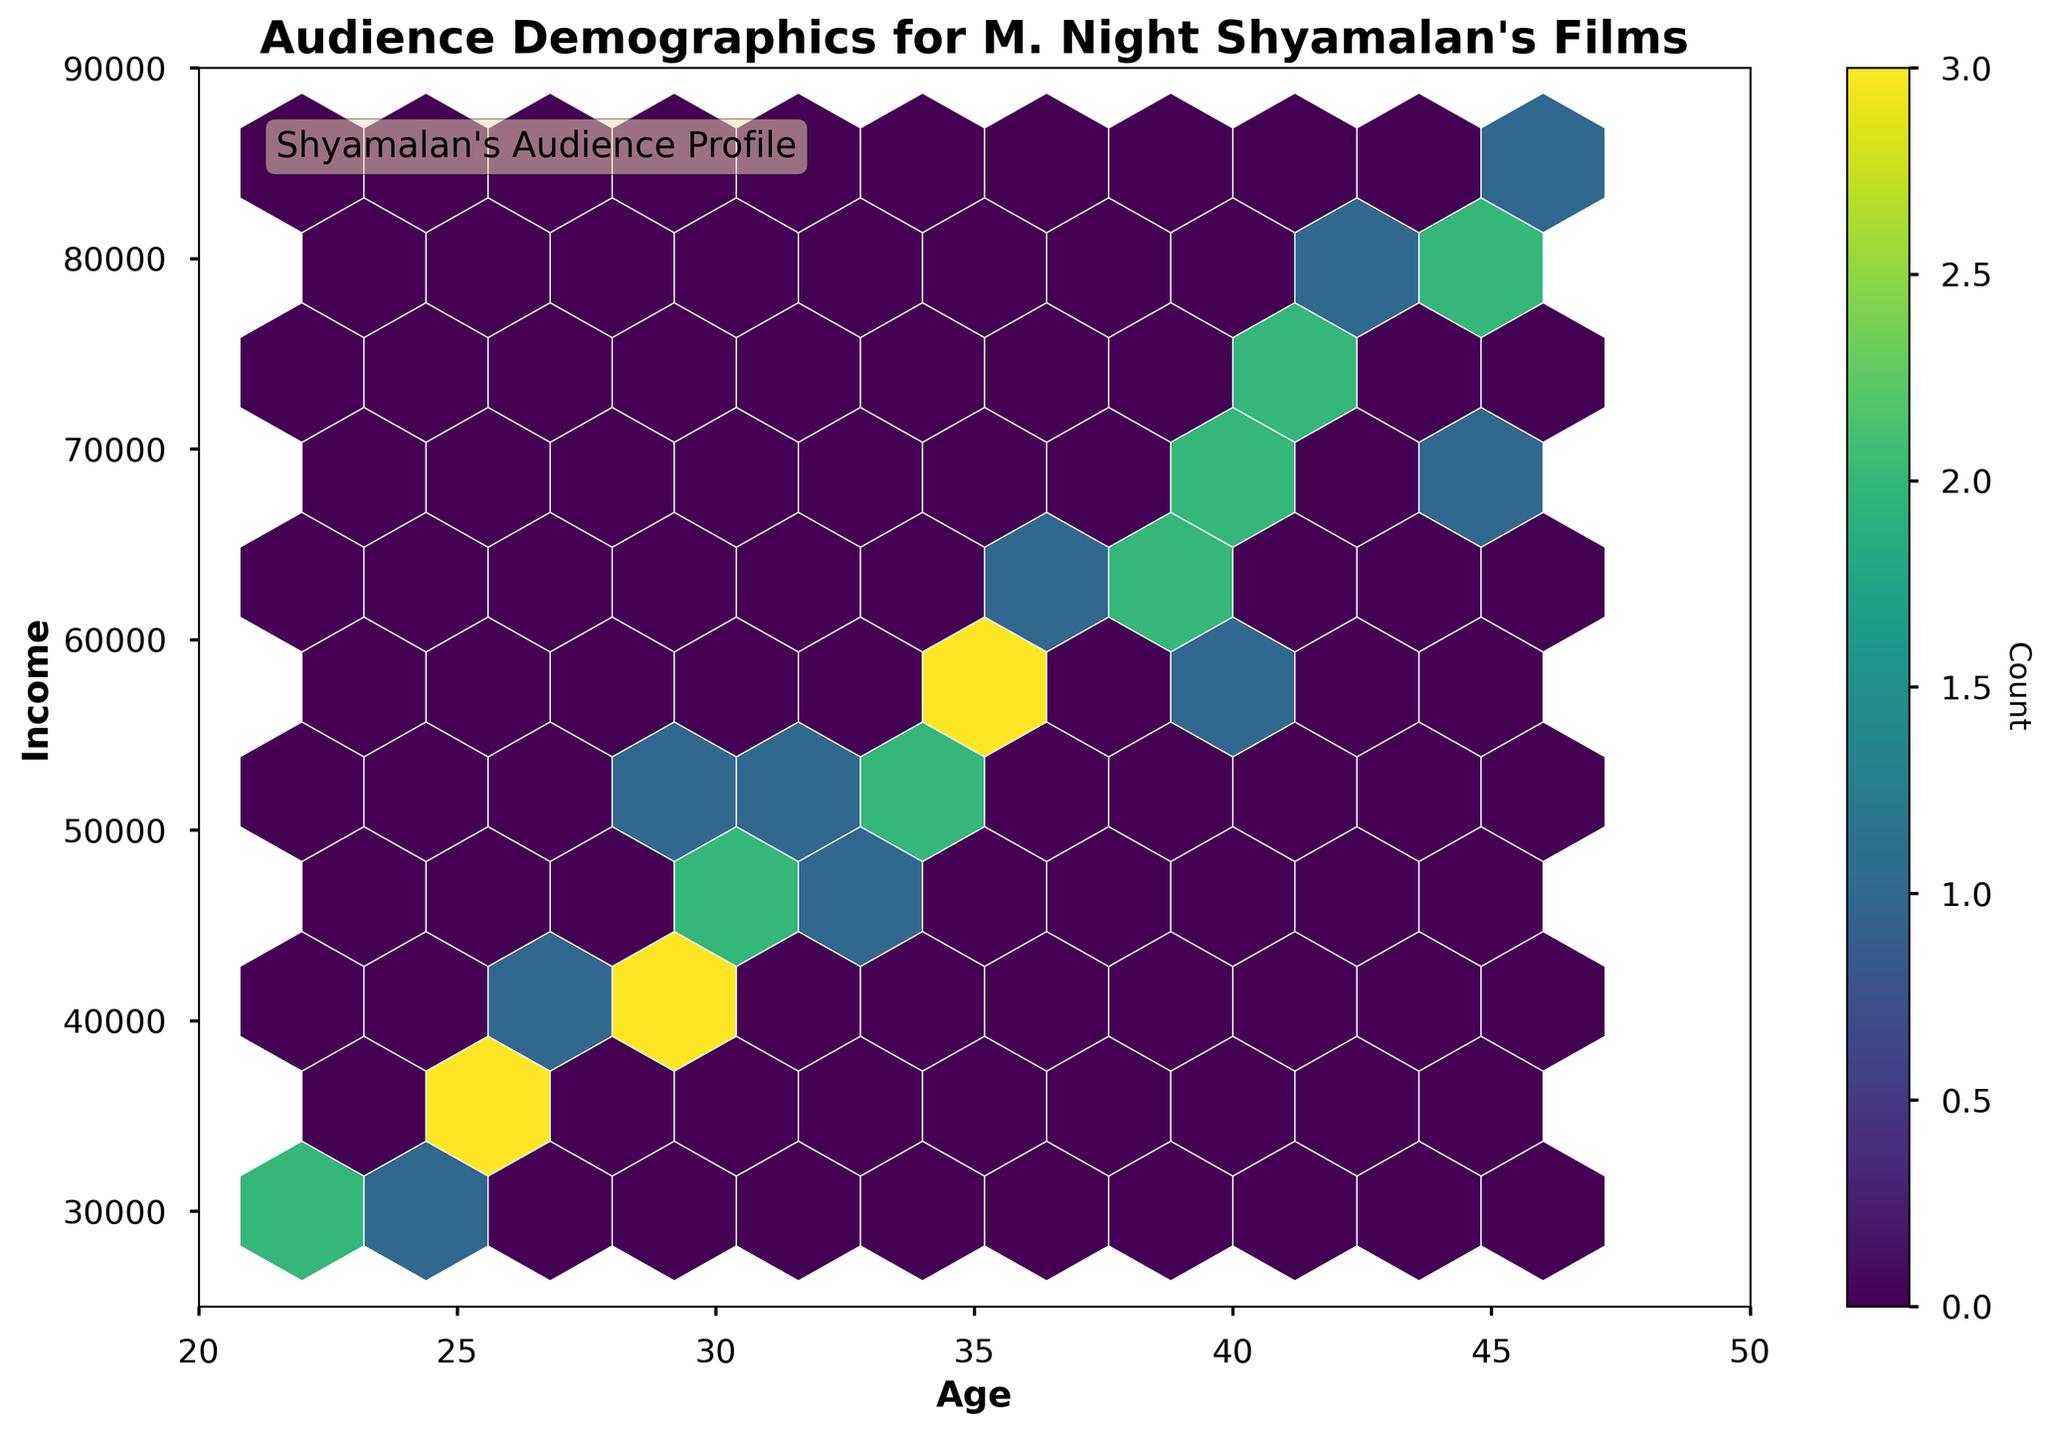How is the distribution of audience age and income depicted? The distribution is shown through a hexbin plot, where hexagonal bins are colored to depict the density of data points. Darker colors indicate higher concentrations of audience members in those age and income brackets.
Answer: Through hexagonal bins with varying color intensities What is the average income range for the age group 25-30? By visually inspecting the hexbin density within the age range 25-30 on the x-axis, the concentration of data points lies between income levels of $35,000 to $50,000.
Answer: $35,000 to $50,000 Which age group tends to have higher incomes, younger (20-30) or older (40-50)? Comparing the concentration of data points (hexagons) in the lower age range (20-30) with the older age range (40-50), the older age group shows a higher density of data points in the upper income levels ($60,000 to $80,000+).
Answer: Older (40-50) In which age and income bracket is the highest density of audience members found? The highest density of audience members is identified by the darkest hexagon on the plot. This is found around the age of 40 with an income around $60,000.
Answer: Age 40, Income $60,000 How does the income distribution change as audience age increases from 20 to 50? Observing the hexbin plot from left to right, income levels tend to increase as age progresses from 20 to 50. Younger audience members have lower income distributions, while older audience members have higher income distributions.
Answer: Income increases with age Are there any age groups where the income distribution appears to be very wide or varied? Age groups in the middle range (around 30-40 years) show a wider distribution of income as compared to younger or older age groups. These middle-age groups have hexagons spread out from lower to higher income levels.
Answer: Middle-age groups (30-40) Which age group has the smallest variation in income levels? The youngest age group (20-25) shows the smallest variation in income levels as their hexagons are less spread out and concentrated in a narrow income band (around $30,000 to $40,000).
Answer: 20-25 What might be the reason for adding a color bar in this hexbin plot? The color bar helps in interpreting the density of data points within each hexagon. Darker colors represent higher density, and lighter colors represent lower density of audience members in those respective age and income brackets.
Answer: To interpret density What specific insights can be derived about the audience demographics for Shyamalan's films from this hexbin plot? The plot shows that Shyamalan's audience primarily includes individuals in their 30s and 40s with income levels ranging mostly from $35,000 to $70,000. The densest areas indicate the most common age-income combinations for his film audience.
Answer: Mainly individuals in their 30s and 40s, incomes $35,000 to $70,000 